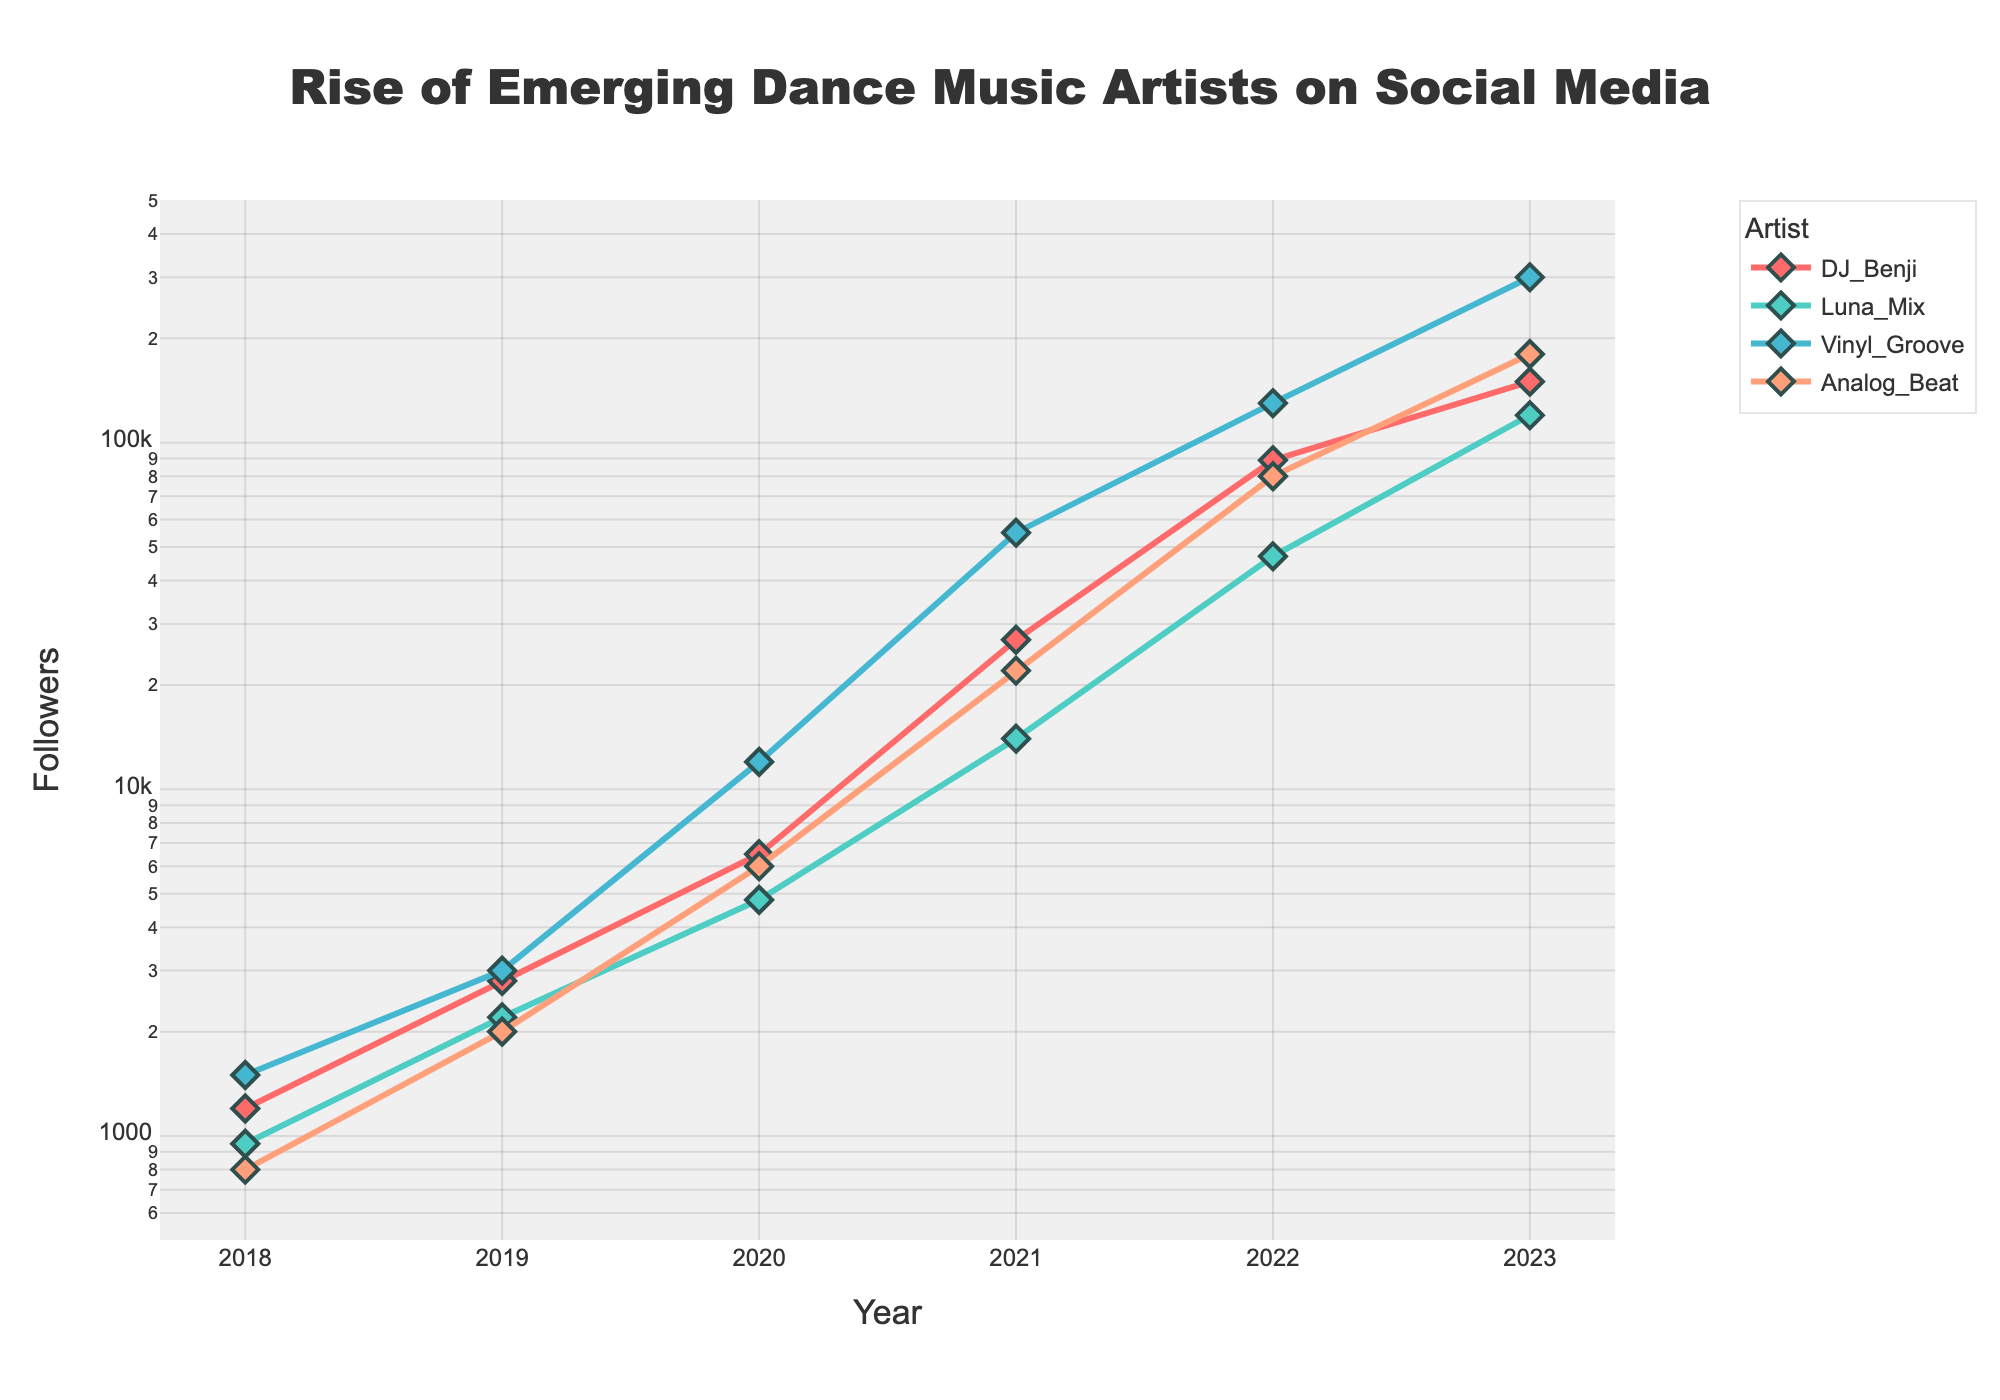What is the title of the plot? The title of the plot is located at the top center of the figure. In this case, it reads "Rise of Emerging Dance Music Artists on Social Media".
Answer: Rise of Emerging Dance Music Artists on Social Media How many data points are there for each artist? Each artist has a point for each of the 6 years represented on the x-axis. Therefore, there are 6 data points for each artist.
Answer: 6 What is the y-axis scale type of the plot? The y-axis uses a logarithmic (log) scale, which is evident by observing the axis labels indicating exponential increases rather than linear.
Answer: Logarithmic Which artist had the highest number of followers in 2023? By looking at the 2023 data points, the highest value is for Vinyl_Groove, which is 300,000.
Answer: Vinyl_Groove Between which two years did DJ_Benji experience the highest rate of increase in followers? DJ_Benji's followers jumped from 6,500 to 27,000 between 2020 and 2021, marking the steepest increase compared to other years.
Answer: 2020 and 2021 Compare the follower growth trend of Luna_Mix and Analog_Beat. Which one shows a steeper rise? Both trends rise, but Analog_Beat's curve is steeper, especially noticeable between 2020 to 2023 where the gap between following increases is larger than that of Luna_Mix.
Answer: Analog_Beat What is the average number of followers of DJ_Benji across the years shown in the plot? Sum of DJ_Benji's followers (1200 + 2800 + 6500 + 27000 + 89000 + 150000) is 276500. The average is 276500 / 6.
Answer: 46083.33 In which year did Vinyl_Groove first surpass 10,000 followers? Vinyl_Groove's follower count crossed the 10,000 mark between 2019 (3,000 followers) and 2020 (12,000 followers).
Answer: 2020 Which artist had the least number of followers in 2018? Observing the data points of all artists in 2018, Analog_Beat had the lowest with 800 followers.
Answer: Analog_Beat How does the increase in followers of Luna_Mix from 2022 to 2023 compare to DJ_Benji's in the same period? Luna_Mix followers increased from 47,000 to 120,000 (73,000 increase), while DJ_Benji’s increased from 89,000 to 150,000 (61,000 increase). Luna_Mix had a bigger increase.
Answer: Luna_Mix 